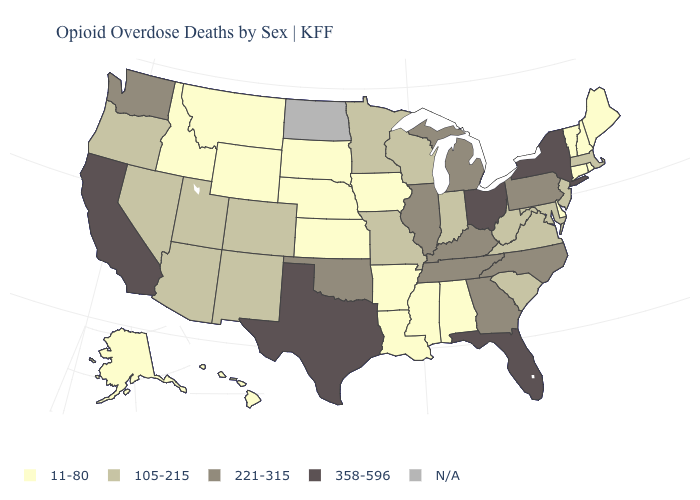Is the legend a continuous bar?
Concise answer only. No. Which states have the highest value in the USA?
Answer briefly. California, Florida, New York, Ohio, Texas. Name the states that have a value in the range 105-215?
Write a very short answer. Arizona, Colorado, Indiana, Maryland, Massachusetts, Minnesota, Missouri, Nevada, New Jersey, New Mexico, Oregon, South Carolina, Utah, Virginia, West Virginia, Wisconsin. What is the lowest value in the USA?
Be succinct. 11-80. Name the states that have a value in the range N/A?
Quick response, please. North Dakota. Does Maine have the highest value in the Northeast?
Be succinct. No. Among the states that border West Virginia , which have the lowest value?
Be succinct. Maryland, Virginia. Among the states that border Oregon , which have the lowest value?
Write a very short answer. Idaho. Does Arizona have the lowest value in the West?
Answer briefly. No. Name the states that have a value in the range N/A?
Short answer required. North Dakota. Does the first symbol in the legend represent the smallest category?
Answer briefly. Yes. Name the states that have a value in the range N/A?
Keep it brief. North Dakota. Does Indiana have the highest value in the USA?
Quick response, please. No. Among the states that border Oregon , does Idaho have the lowest value?
Be succinct. Yes. 